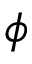<formula> <loc_0><loc_0><loc_500><loc_500>\phi</formula> 